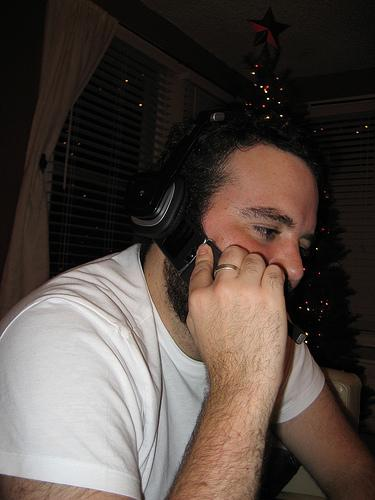What sentiment or mood does the image convey? The image conveys a casual, everyday mood with a hint of festive spirit from the Christmas tree. Describe the type of tree seen in the background of this image. There is a decorated Christmas tree with lights and a large red star on top in the background. Count and describe different window coverings present in the image. There are three different window coverings: white window blinds, white window curtains, and mini blinds (dark and light colored). Can you provide a short description of this image, mentioning the most prominent objects? The image features a man talking on a cell phone, wearing a headset and a ring, with Christmas tree and window blinds in the background. How many times does "black flip phone on a mans ear" appear in the image data? The phrase "black flip phone on a mans ear" appears ten times in the image data. What action does the man perform with one of his hands in the image? The man in the image is holding a cell phone to his ear while talking. Identify the type of phone the man is using in this image. The man is using a black flip cell phone. What type of accessory is the man using while he talks on his phone? The man is wearing a headset while talking on his phone. What is a distinctive feature of the man's appearance in this image? A distinctive feature of the man's appearance is his thick black eyebrows and black hair. How many objects related to the Christmas tree are identified in the image data? There are six objects related to the Christmas tree in the image data. What is the man holding near his ear? A black flip cell phone What color are the window blinds in the image? White Describe the color and pattern of the window curtains. White and sheer What type of item is shining on the man's finger? A silver wedding ring What is the man doing with the headphones? Listening to music What type of tree is present in the image, and what is unique about it? A Christmas tree with lights and decorations What are the curtains on the window made of? Sheer white panel Is the man concentrating on something while using his cell phone?  Yes, he's talking on the phone What specific type of tree is in the image? A large Christmas tree with some decorations on it Identify the moonlight reflecting off of the water outside the window. No, it's not mentioned in the image. What is the man wearing around his head, and what might he be doing with it? A black headset. He might be listening to music or talking on the phone. What specific decoration is on top of the Christmas tree? A large red star Describe one detail about the man's hand. Hairy arm What type of blinds are on the window? White mini blinds Describe the man's hairstyle. Black hair Identify the festive object in the image. A decorated Christmas tree Which of these options describe the man's attire? A) White t-shirt, B) Blue suit, C) Striped sweater. A) White t-shirt Which action is the man performing? A) Eating, B) Talking on the phone, C) Typing on a laptop. B) Talking on the phone What is on the man's head? A black headset 